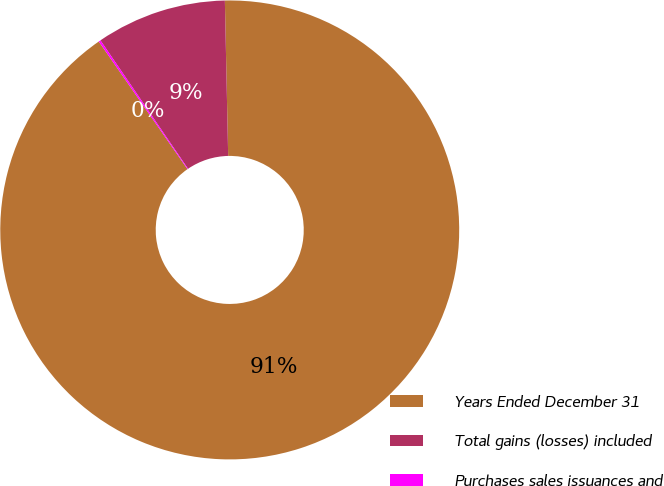Convert chart to OTSL. <chart><loc_0><loc_0><loc_500><loc_500><pie_chart><fcel>Years Ended December 31<fcel>Total gains (losses) included<fcel>Purchases sales issuances and<nl><fcel>90.68%<fcel>9.19%<fcel>0.14%<nl></chart> 